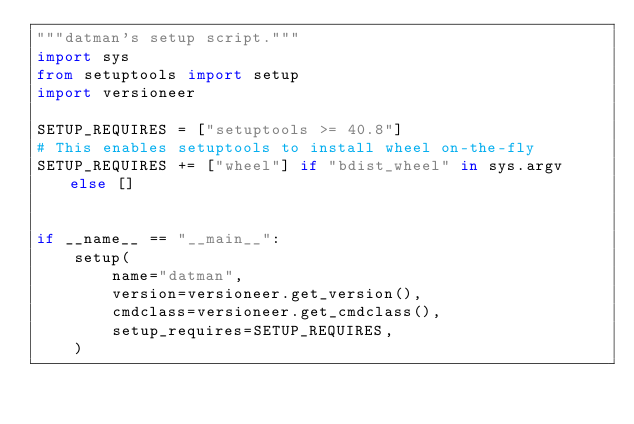<code> <loc_0><loc_0><loc_500><loc_500><_Python_>"""datman's setup script."""
import sys
from setuptools import setup
import versioneer

SETUP_REQUIRES = ["setuptools >= 40.8"]
# This enables setuptools to install wheel on-the-fly
SETUP_REQUIRES += ["wheel"] if "bdist_wheel" in sys.argv else []


if __name__ == "__main__":
    setup(
        name="datman",
        version=versioneer.get_version(),
        cmdclass=versioneer.get_cmdclass(),
        setup_requires=SETUP_REQUIRES,
    )
</code> 